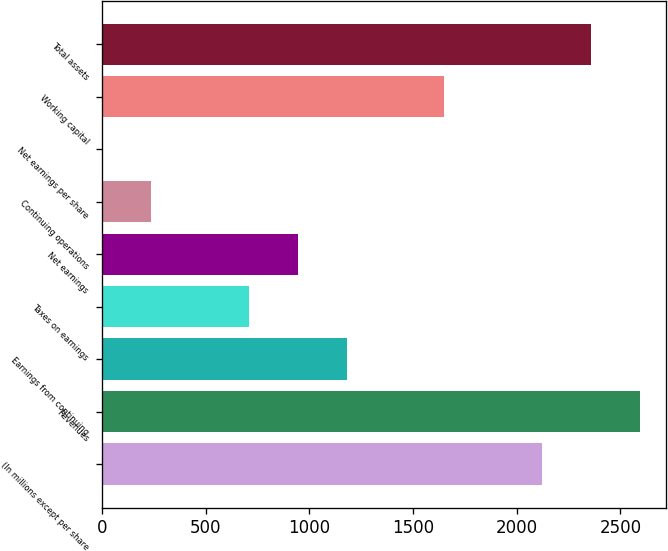<chart> <loc_0><loc_0><loc_500><loc_500><bar_chart><fcel>(In millions except per share<fcel>Revenues<fcel>Earnings from continuing<fcel>Taxes on earnings<fcel>Net earnings<fcel>Continuing operations<fcel>Net earnings per share<fcel>Working capital<fcel>Total assets<nl><fcel>2121.2<fcel>2591.92<fcel>1179.76<fcel>709.04<fcel>944.4<fcel>238.32<fcel>2.96<fcel>1650.48<fcel>2356.56<nl></chart> 